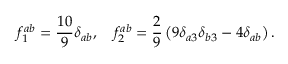<formula> <loc_0><loc_0><loc_500><loc_500>f _ { 1 } ^ { a b } = \frac { 1 0 } { 9 } \delta _ { a b } , \quad f _ { 2 } ^ { a b } = \frac { 2 } { 9 } \left ( 9 \delta _ { a 3 } \delta _ { b 3 } - 4 \delta _ { a b } \right ) .</formula> 